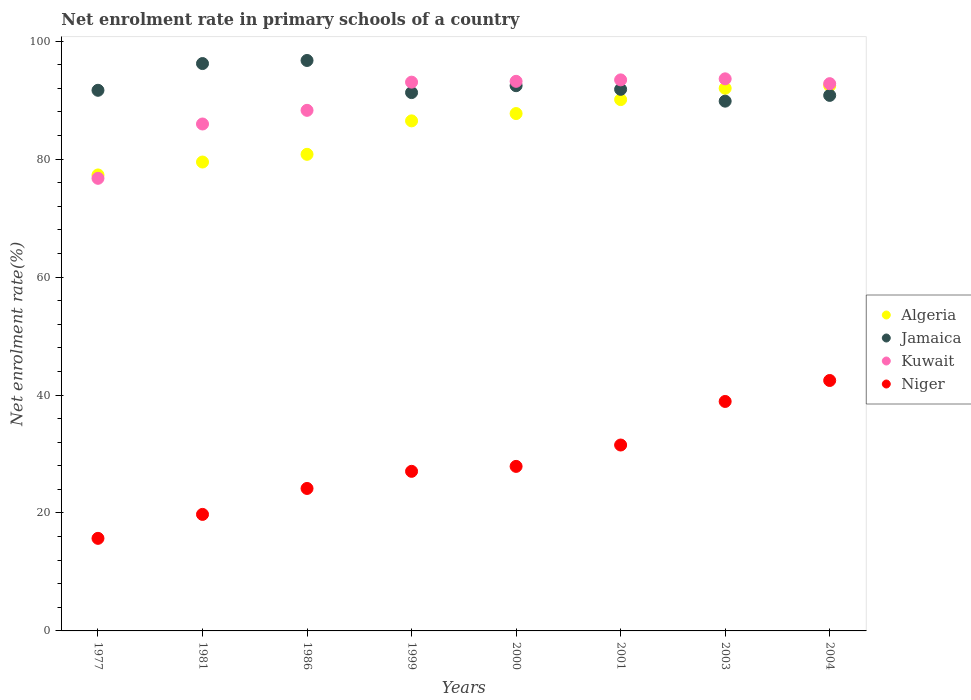How many different coloured dotlines are there?
Make the answer very short. 4. What is the net enrolment rate in primary schools in Algeria in 1999?
Make the answer very short. 86.49. Across all years, what is the maximum net enrolment rate in primary schools in Jamaica?
Ensure brevity in your answer.  96.73. Across all years, what is the minimum net enrolment rate in primary schools in Kuwait?
Your response must be concise. 76.75. In which year was the net enrolment rate in primary schools in Niger maximum?
Make the answer very short. 2004. What is the total net enrolment rate in primary schools in Kuwait in the graph?
Your answer should be very brief. 717.06. What is the difference between the net enrolment rate in primary schools in Niger in 2003 and that in 2004?
Make the answer very short. -3.55. What is the difference between the net enrolment rate in primary schools in Algeria in 2004 and the net enrolment rate in primary schools in Kuwait in 1981?
Give a very brief answer. 6.49. What is the average net enrolment rate in primary schools in Jamaica per year?
Ensure brevity in your answer.  92.6. In the year 1986, what is the difference between the net enrolment rate in primary schools in Kuwait and net enrolment rate in primary schools in Algeria?
Keep it short and to the point. 7.46. In how many years, is the net enrolment rate in primary schools in Kuwait greater than 40 %?
Offer a very short reply. 8. What is the ratio of the net enrolment rate in primary schools in Algeria in 1981 to that in 2003?
Your answer should be compact. 0.86. What is the difference between the highest and the second highest net enrolment rate in primary schools in Algeria?
Ensure brevity in your answer.  0.44. What is the difference between the highest and the lowest net enrolment rate in primary schools in Niger?
Offer a very short reply. 26.77. Is the sum of the net enrolment rate in primary schools in Niger in 2000 and 2001 greater than the maximum net enrolment rate in primary schools in Jamaica across all years?
Your response must be concise. No. Is it the case that in every year, the sum of the net enrolment rate in primary schools in Kuwait and net enrolment rate in primary schools in Jamaica  is greater than the sum of net enrolment rate in primary schools in Algeria and net enrolment rate in primary schools in Niger?
Ensure brevity in your answer.  No. Is it the case that in every year, the sum of the net enrolment rate in primary schools in Kuwait and net enrolment rate in primary schools in Niger  is greater than the net enrolment rate in primary schools in Jamaica?
Ensure brevity in your answer.  Yes. Is the net enrolment rate in primary schools in Kuwait strictly less than the net enrolment rate in primary schools in Niger over the years?
Your response must be concise. No. How many dotlines are there?
Provide a short and direct response. 4. Are the values on the major ticks of Y-axis written in scientific E-notation?
Ensure brevity in your answer.  No. How many legend labels are there?
Make the answer very short. 4. What is the title of the graph?
Your answer should be compact. Net enrolment rate in primary schools of a country. Does "Virgin Islands" appear as one of the legend labels in the graph?
Your response must be concise. No. What is the label or title of the Y-axis?
Offer a very short reply. Net enrolment rate(%). What is the Net enrolment rate(%) of Algeria in 1977?
Your answer should be compact. 77.32. What is the Net enrolment rate(%) in Jamaica in 1977?
Provide a succinct answer. 91.67. What is the Net enrolment rate(%) of Kuwait in 1977?
Provide a succinct answer. 76.75. What is the Net enrolment rate(%) of Niger in 1977?
Ensure brevity in your answer.  15.7. What is the Net enrolment rate(%) in Algeria in 1981?
Offer a terse response. 79.51. What is the Net enrolment rate(%) in Jamaica in 1981?
Your answer should be very brief. 96.2. What is the Net enrolment rate(%) of Kuwait in 1981?
Offer a very short reply. 85.96. What is the Net enrolment rate(%) of Niger in 1981?
Keep it short and to the point. 19.76. What is the Net enrolment rate(%) in Algeria in 1986?
Ensure brevity in your answer.  80.81. What is the Net enrolment rate(%) of Jamaica in 1986?
Your answer should be compact. 96.73. What is the Net enrolment rate(%) of Kuwait in 1986?
Your response must be concise. 88.27. What is the Net enrolment rate(%) in Niger in 1986?
Your answer should be very brief. 24.16. What is the Net enrolment rate(%) in Algeria in 1999?
Your answer should be compact. 86.49. What is the Net enrolment rate(%) in Jamaica in 1999?
Make the answer very short. 91.28. What is the Net enrolment rate(%) of Kuwait in 1999?
Your answer should be very brief. 93.05. What is the Net enrolment rate(%) in Niger in 1999?
Your answer should be very brief. 27.06. What is the Net enrolment rate(%) of Algeria in 2000?
Your response must be concise. 87.73. What is the Net enrolment rate(%) in Jamaica in 2000?
Your response must be concise. 92.45. What is the Net enrolment rate(%) in Kuwait in 2000?
Your answer should be compact. 93.19. What is the Net enrolment rate(%) in Niger in 2000?
Keep it short and to the point. 27.9. What is the Net enrolment rate(%) in Algeria in 2001?
Offer a very short reply. 90.09. What is the Net enrolment rate(%) in Jamaica in 2001?
Make the answer very short. 91.83. What is the Net enrolment rate(%) in Kuwait in 2001?
Your answer should be very brief. 93.44. What is the Net enrolment rate(%) in Niger in 2001?
Provide a succinct answer. 31.52. What is the Net enrolment rate(%) in Algeria in 2003?
Keep it short and to the point. 92.01. What is the Net enrolment rate(%) of Jamaica in 2003?
Offer a terse response. 89.83. What is the Net enrolment rate(%) of Kuwait in 2003?
Your answer should be very brief. 93.61. What is the Net enrolment rate(%) in Niger in 2003?
Ensure brevity in your answer.  38.91. What is the Net enrolment rate(%) of Algeria in 2004?
Offer a very short reply. 92.45. What is the Net enrolment rate(%) in Jamaica in 2004?
Your answer should be compact. 90.81. What is the Net enrolment rate(%) in Kuwait in 2004?
Your answer should be very brief. 92.79. What is the Net enrolment rate(%) of Niger in 2004?
Offer a terse response. 42.46. Across all years, what is the maximum Net enrolment rate(%) in Algeria?
Ensure brevity in your answer.  92.45. Across all years, what is the maximum Net enrolment rate(%) of Jamaica?
Your answer should be compact. 96.73. Across all years, what is the maximum Net enrolment rate(%) of Kuwait?
Your answer should be compact. 93.61. Across all years, what is the maximum Net enrolment rate(%) in Niger?
Provide a succinct answer. 42.46. Across all years, what is the minimum Net enrolment rate(%) of Algeria?
Your response must be concise. 77.32. Across all years, what is the minimum Net enrolment rate(%) in Jamaica?
Give a very brief answer. 89.83. Across all years, what is the minimum Net enrolment rate(%) of Kuwait?
Your response must be concise. 76.75. Across all years, what is the minimum Net enrolment rate(%) of Niger?
Your response must be concise. 15.7. What is the total Net enrolment rate(%) of Algeria in the graph?
Your answer should be very brief. 686.4. What is the total Net enrolment rate(%) of Jamaica in the graph?
Provide a short and direct response. 740.8. What is the total Net enrolment rate(%) of Kuwait in the graph?
Ensure brevity in your answer.  717.06. What is the total Net enrolment rate(%) of Niger in the graph?
Offer a terse response. 227.47. What is the difference between the Net enrolment rate(%) of Algeria in 1977 and that in 1981?
Your answer should be compact. -2.19. What is the difference between the Net enrolment rate(%) of Jamaica in 1977 and that in 1981?
Your answer should be compact. -4.53. What is the difference between the Net enrolment rate(%) in Kuwait in 1977 and that in 1981?
Your answer should be very brief. -9.21. What is the difference between the Net enrolment rate(%) of Niger in 1977 and that in 1981?
Ensure brevity in your answer.  -4.06. What is the difference between the Net enrolment rate(%) of Algeria in 1977 and that in 1986?
Give a very brief answer. -3.5. What is the difference between the Net enrolment rate(%) of Jamaica in 1977 and that in 1986?
Your answer should be compact. -5.06. What is the difference between the Net enrolment rate(%) in Kuwait in 1977 and that in 1986?
Keep it short and to the point. -11.53. What is the difference between the Net enrolment rate(%) of Niger in 1977 and that in 1986?
Give a very brief answer. -8.46. What is the difference between the Net enrolment rate(%) in Algeria in 1977 and that in 1999?
Provide a short and direct response. -9.17. What is the difference between the Net enrolment rate(%) of Jamaica in 1977 and that in 1999?
Offer a very short reply. 0.39. What is the difference between the Net enrolment rate(%) in Kuwait in 1977 and that in 1999?
Provide a short and direct response. -16.31. What is the difference between the Net enrolment rate(%) in Niger in 1977 and that in 1999?
Your answer should be very brief. -11.36. What is the difference between the Net enrolment rate(%) in Algeria in 1977 and that in 2000?
Offer a very short reply. -10.41. What is the difference between the Net enrolment rate(%) of Jamaica in 1977 and that in 2000?
Provide a short and direct response. -0.78. What is the difference between the Net enrolment rate(%) in Kuwait in 1977 and that in 2000?
Keep it short and to the point. -16.44. What is the difference between the Net enrolment rate(%) in Niger in 1977 and that in 2000?
Provide a short and direct response. -12.2. What is the difference between the Net enrolment rate(%) in Algeria in 1977 and that in 2001?
Offer a very short reply. -12.78. What is the difference between the Net enrolment rate(%) in Jamaica in 1977 and that in 2001?
Provide a succinct answer. -0.16. What is the difference between the Net enrolment rate(%) of Kuwait in 1977 and that in 2001?
Offer a terse response. -16.69. What is the difference between the Net enrolment rate(%) in Niger in 1977 and that in 2001?
Offer a very short reply. -15.83. What is the difference between the Net enrolment rate(%) of Algeria in 1977 and that in 2003?
Provide a succinct answer. -14.7. What is the difference between the Net enrolment rate(%) in Jamaica in 1977 and that in 2003?
Your answer should be compact. 1.84. What is the difference between the Net enrolment rate(%) in Kuwait in 1977 and that in 2003?
Your answer should be very brief. -16.87. What is the difference between the Net enrolment rate(%) of Niger in 1977 and that in 2003?
Offer a terse response. -23.21. What is the difference between the Net enrolment rate(%) in Algeria in 1977 and that in 2004?
Make the answer very short. -15.13. What is the difference between the Net enrolment rate(%) of Jamaica in 1977 and that in 2004?
Your answer should be compact. 0.86. What is the difference between the Net enrolment rate(%) in Kuwait in 1977 and that in 2004?
Keep it short and to the point. -16.05. What is the difference between the Net enrolment rate(%) of Niger in 1977 and that in 2004?
Provide a succinct answer. -26.77. What is the difference between the Net enrolment rate(%) of Algeria in 1981 and that in 1986?
Ensure brevity in your answer.  -1.31. What is the difference between the Net enrolment rate(%) of Jamaica in 1981 and that in 1986?
Your answer should be very brief. -0.52. What is the difference between the Net enrolment rate(%) of Kuwait in 1981 and that in 1986?
Provide a short and direct response. -2.32. What is the difference between the Net enrolment rate(%) in Niger in 1981 and that in 1986?
Ensure brevity in your answer.  -4.4. What is the difference between the Net enrolment rate(%) in Algeria in 1981 and that in 1999?
Offer a terse response. -6.98. What is the difference between the Net enrolment rate(%) in Jamaica in 1981 and that in 1999?
Give a very brief answer. 4.92. What is the difference between the Net enrolment rate(%) in Kuwait in 1981 and that in 1999?
Provide a succinct answer. -7.09. What is the difference between the Net enrolment rate(%) in Niger in 1981 and that in 1999?
Keep it short and to the point. -7.3. What is the difference between the Net enrolment rate(%) of Algeria in 1981 and that in 2000?
Give a very brief answer. -8.22. What is the difference between the Net enrolment rate(%) in Jamaica in 1981 and that in 2000?
Ensure brevity in your answer.  3.75. What is the difference between the Net enrolment rate(%) in Kuwait in 1981 and that in 2000?
Provide a succinct answer. -7.23. What is the difference between the Net enrolment rate(%) of Niger in 1981 and that in 2000?
Keep it short and to the point. -8.14. What is the difference between the Net enrolment rate(%) in Algeria in 1981 and that in 2001?
Provide a succinct answer. -10.59. What is the difference between the Net enrolment rate(%) of Jamaica in 1981 and that in 2001?
Keep it short and to the point. 4.37. What is the difference between the Net enrolment rate(%) of Kuwait in 1981 and that in 2001?
Make the answer very short. -7.48. What is the difference between the Net enrolment rate(%) in Niger in 1981 and that in 2001?
Keep it short and to the point. -11.76. What is the difference between the Net enrolment rate(%) in Algeria in 1981 and that in 2003?
Provide a short and direct response. -12.51. What is the difference between the Net enrolment rate(%) in Jamaica in 1981 and that in 2003?
Provide a succinct answer. 6.38. What is the difference between the Net enrolment rate(%) in Kuwait in 1981 and that in 2003?
Provide a short and direct response. -7.66. What is the difference between the Net enrolment rate(%) of Niger in 1981 and that in 2003?
Keep it short and to the point. -19.15. What is the difference between the Net enrolment rate(%) of Algeria in 1981 and that in 2004?
Your answer should be very brief. -12.94. What is the difference between the Net enrolment rate(%) of Jamaica in 1981 and that in 2004?
Your answer should be compact. 5.4. What is the difference between the Net enrolment rate(%) in Kuwait in 1981 and that in 2004?
Keep it short and to the point. -6.84. What is the difference between the Net enrolment rate(%) of Niger in 1981 and that in 2004?
Your response must be concise. -22.71. What is the difference between the Net enrolment rate(%) of Algeria in 1986 and that in 1999?
Offer a very short reply. -5.67. What is the difference between the Net enrolment rate(%) in Jamaica in 1986 and that in 1999?
Your answer should be very brief. 5.45. What is the difference between the Net enrolment rate(%) in Kuwait in 1986 and that in 1999?
Keep it short and to the point. -4.78. What is the difference between the Net enrolment rate(%) in Niger in 1986 and that in 1999?
Provide a short and direct response. -2.9. What is the difference between the Net enrolment rate(%) of Algeria in 1986 and that in 2000?
Your answer should be very brief. -6.91. What is the difference between the Net enrolment rate(%) of Jamaica in 1986 and that in 2000?
Provide a succinct answer. 4.28. What is the difference between the Net enrolment rate(%) of Kuwait in 1986 and that in 2000?
Your answer should be compact. -4.92. What is the difference between the Net enrolment rate(%) in Niger in 1986 and that in 2000?
Offer a very short reply. -3.74. What is the difference between the Net enrolment rate(%) of Algeria in 1986 and that in 2001?
Provide a succinct answer. -9.28. What is the difference between the Net enrolment rate(%) of Jamaica in 1986 and that in 2001?
Give a very brief answer. 4.89. What is the difference between the Net enrolment rate(%) in Kuwait in 1986 and that in 2001?
Your response must be concise. -5.16. What is the difference between the Net enrolment rate(%) of Niger in 1986 and that in 2001?
Provide a succinct answer. -7.37. What is the difference between the Net enrolment rate(%) in Algeria in 1986 and that in 2003?
Your answer should be very brief. -11.2. What is the difference between the Net enrolment rate(%) of Jamaica in 1986 and that in 2003?
Your answer should be very brief. 6.9. What is the difference between the Net enrolment rate(%) in Kuwait in 1986 and that in 2003?
Ensure brevity in your answer.  -5.34. What is the difference between the Net enrolment rate(%) of Niger in 1986 and that in 2003?
Ensure brevity in your answer.  -14.75. What is the difference between the Net enrolment rate(%) in Algeria in 1986 and that in 2004?
Your answer should be compact. -11.63. What is the difference between the Net enrolment rate(%) in Jamaica in 1986 and that in 2004?
Your response must be concise. 5.92. What is the difference between the Net enrolment rate(%) of Kuwait in 1986 and that in 2004?
Your response must be concise. -4.52. What is the difference between the Net enrolment rate(%) in Niger in 1986 and that in 2004?
Provide a succinct answer. -18.31. What is the difference between the Net enrolment rate(%) of Algeria in 1999 and that in 2000?
Your answer should be very brief. -1.24. What is the difference between the Net enrolment rate(%) of Jamaica in 1999 and that in 2000?
Keep it short and to the point. -1.17. What is the difference between the Net enrolment rate(%) of Kuwait in 1999 and that in 2000?
Your response must be concise. -0.14. What is the difference between the Net enrolment rate(%) of Niger in 1999 and that in 2000?
Your answer should be compact. -0.84. What is the difference between the Net enrolment rate(%) of Algeria in 1999 and that in 2001?
Keep it short and to the point. -3.61. What is the difference between the Net enrolment rate(%) of Jamaica in 1999 and that in 2001?
Ensure brevity in your answer.  -0.55. What is the difference between the Net enrolment rate(%) in Kuwait in 1999 and that in 2001?
Offer a very short reply. -0.38. What is the difference between the Net enrolment rate(%) in Niger in 1999 and that in 2001?
Provide a short and direct response. -4.46. What is the difference between the Net enrolment rate(%) in Algeria in 1999 and that in 2003?
Make the answer very short. -5.53. What is the difference between the Net enrolment rate(%) in Jamaica in 1999 and that in 2003?
Offer a very short reply. 1.45. What is the difference between the Net enrolment rate(%) in Kuwait in 1999 and that in 2003?
Ensure brevity in your answer.  -0.56. What is the difference between the Net enrolment rate(%) of Niger in 1999 and that in 2003?
Make the answer very short. -11.85. What is the difference between the Net enrolment rate(%) of Algeria in 1999 and that in 2004?
Offer a very short reply. -5.96. What is the difference between the Net enrolment rate(%) of Jamaica in 1999 and that in 2004?
Offer a very short reply. 0.47. What is the difference between the Net enrolment rate(%) of Kuwait in 1999 and that in 2004?
Your answer should be very brief. 0.26. What is the difference between the Net enrolment rate(%) of Niger in 1999 and that in 2004?
Give a very brief answer. -15.4. What is the difference between the Net enrolment rate(%) of Algeria in 2000 and that in 2001?
Your answer should be very brief. -2.37. What is the difference between the Net enrolment rate(%) of Jamaica in 2000 and that in 2001?
Your response must be concise. 0.62. What is the difference between the Net enrolment rate(%) in Kuwait in 2000 and that in 2001?
Provide a short and direct response. -0.24. What is the difference between the Net enrolment rate(%) of Niger in 2000 and that in 2001?
Keep it short and to the point. -3.62. What is the difference between the Net enrolment rate(%) in Algeria in 2000 and that in 2003?
Ensure brevity in your answer.  -4.29. What is the difference between the Net enrolment rate(%) of Jamaica in 2000 and that in 2003?
Provide a succinct answer. 2.62. What is the difference between the Net enrolment rate(%) of Kuwait in 2000 and that in 2003?
Make the answer very short. -0.42. What is the difference between the Net enrolment rate(%) of Niger in 2000 and that in 2003?
Offer a terse response. -11.01. What is the difference between the Net enrolment rate(%) in Algeria in 2000 and that in 2004?
Ensure brevity in your answer.  -4.72. What is the difference between the Net enrolment rate(%) in Jamaica in 2000 and that in 2004?
Provide a succinct answer. 1.64. What is the difference between the Net enrolment rate(%) in Kuwait in 2000 and that in 2004?
Make the answer very short. 0.4. What is the difference between the Net enrolment rate(%) of Niger in 2000 and that in 2004?
Offer a terse response. -14.57. What is the difference between the Net enrolment rate(%) of Algeria in 2001 and that in 2003?
Your response must be concise. -1.92. What is the difference between the Net enrolment rate(%) of Jamaica in 2001 and that in 2003?
Your answer should be compact. 2. What is the difference between the Net enrolment rate(%) of Kuwait in 2001 and that in 2003?
Keep it short and to the point. -0.18. What is the difference between the Net enrolment rate(%) in Niger in 2001 and that in 2003?
Your answer should be compact. -7.39. What is the difference between the Net enrolment rate(%) of Algeria in 2001 and that in 2004?
Provide a succinct answer. -2.36. What is the difference between the Net enrolment rate(%) of Jamaica in 2001 and that in 2004?
Your response must be concise. 1.03. What is the difference between the Net enrolment rate(%) in Kuwait in 2001 and that in 2004?
Ensure brevity in your answer.  0.64. What is the difference between the Net enrolment rate(%) of Niger in 2001 and that in 2004?
Your response must be concise. -10.94. What is the difference between the Net enrolment rate(%) of Algeria in 2003 and that in 2004?
Provide a short and direct response. -0.44. What is the difference between the Net enrolment rate(%) in Jamaica in 2003 and that in 2004?
Keep it short and to the point. -0.98. What is the difference between the Net enrolment rate(%) in Kuwait in 2003 and that in 2004?
Your answer should be very brief. 0.82. What is the difference between the Net enrolment rate(%) of Niger in 2003 and that in 2004?
Make the answer very short. -3.55. What is the difference between the Net enrolment rate(%) of Algeria in 1977 and the Net enrolment rate(%) of Jamaica in 1981?
Your answer should be very brief. -18.89. What is the difference between the Net enrolment rate(%) of Algeria in 1977 and the Net enrolment rate(%) of Kuwait in 1981?
Provide a succinct answer. -8.64. What is the difference between the Net enrolment rate(%) of Algeria in 1977 and the Net enrolment rate(%) of Niger in 1981?
Provide a short and direct response. 57.56. What is the difference between the Net enrolment rate(%) in Jamaica in 1977 and the Net enrolment rate(%) in Kuwait in 1981?
Offer a terse response. 5.71. What is the difference between the Net enrolment rate(%) in Jamaica in 1977 and the Net enrolment rate(%) in Niger in 1981?
Your response must be concise. 71.91. What is the difference between the Net enrolment rate(%) in Kuwait in 1977 and the Net enrolment rate(%) in Niger in 1981?
Give a very brief answer. 56.99. What is the difference between the Net enrolment rate(%) of Algeria in 1977 and the Net enrolment rate(%) of Jamaica in 1986?
Your response must be concise. -19.41. What is the difference between the Net enrolment rate(%) of Algeria in 1977 and the Net enrolment rate(%) of Kuwait in 1986?
Offer a terse response. -10.96. What is the difference between the Net enrolment rate(%) in Algeria in 1977 and the Net enrolment rate(%) in Niger in 1986?
Offer a very short reply. 53.16. What is the difference between the Net enrolment rate(%) of Jamaica in 1977 and the Net enrolment rate(%) of Kuwait in 1986?
Keep it short and to the point. 3.4. What is the difference between the Net enrolment rate(%) of Jamaica in 1977 and the Net enrolment rate(%) of Niger in 1986?
Provide a short and direct response. 67.51. What is the difference between the Net enrolment rate(%) of Kuwait in 1977 and the Net enrolment rate(%) of Niger in 1986?
Give a very brief answer. 52.59. What is the difference between the Net enrolment rate(%) in Algeria in 1977 and the Net enrolment rate(%) in Jamaica in 1999?
Offer a very short reply. -13.96. What is the difference between the Net enrolment rate(%) of Algeria in 1977 and the Net enrolment rate(%) of Kuwait in 1999?
Provide a succinct answer. -15.73. What is the difference between the Net enrolment rate(%) of Algeria in 1977 and the Net enrolment rate(%) of Niger in 1999?
Keep it short and to the point. 50.26. What is the difference between the Net enrolment rate(%) in Jamaica in 1977 and the Net enrolment rate(%) in Kuwait in 1999?
Your answer should be compact. -1.38. What is the difference between the Net enrolment rate(%) of Jamaica in 1977 and the Net enrolment rate(%) of Niger in 1999?
Provide a short and direct response. 64.61. What is the difference between the Net enrolment rate(%) of Kuwait in 1977 and the Net enrolment rate(%) of Niger in 1999?
Ensure brevity in your answer.  49.69. What is the difference between the Net enrolment rate(%) of Algeria in 1977 and the Net enrolment rate(%) of Jamaica in 2000?
Give a very brief answer. -15.13. What is the difference between the Net enrolment rate(%) of Algeria in 1977 and the Net enrolment rate(%) of Kuwait in 2000?
Your answer should be compact. -15.87. What is the difference between the Net enrolment rate(%) in Algeria in 1977 and the Net enrolment rate(%) in Niger in 2000?
Offer a very short reply. 49.42. What is the difference between the Net enrolment rate(%) in Jamaica in 1977 and the Net enrolment rate(%) in Kuwait in 2000?
Your answer should be compact. -1.52. What is the difference between the Net enrolment rate(%) in Jamaica in 1977 and the Net enrolment rate(%) in Niger in 2000?
Provide a short and direct response. 63.77. What is the difference between the Net enrolment rate(%) in Kuwait in 1977 and the Net enrolment rate(%) in Niger in 2000?
Offer a terse response. 48.85. What is the difference between the Net enrolment rate(%) in Algeria in 1977 and the Net enrolment rate(%) in Jamaica in 2001?
Provide a short and direct response. -14.52. What is the difference between the Net enrolment rate(%) of Algeria in 1977 and the Net enrolment rate(%) of Kuwait in 2001?
Offer a terse response. -16.12. What is the difference between the Net enrolment rate(%) of Algeria in 1977 and the Net enrolment rate(%) of Niger in 2001?
Make the answer very short. 45.79. What is the difference between the Net enrolment rate(%) in Jamaica in 1977 and the Net enrolment rate(%) in Kuwait in 2001?
Provide a short and direct response. -1.76. What is the difference between the Net enrolment rate(%) of Jamaica in 1977 and the Net enrolment rate(%) of Niger in 2001?
Keep it short and to the point. 60.15. What is the difference between the Net enrolment rate(%) of Kuwait in 1977 and the Net enrolment rate(%) of Niger in 2001?
Keep it short and to the point. 45.22. What is the difference between the Net enrolment rate(%) of Algeria in 1977 and the Net enrolment rate(%) of Jamaica in 2003?
Provide a succinct answer. -12.51. What is the difference between the Net enrolment rate(%) of Algeria in 1977 and the Net enrolment rate(%) of Kuwait in 2003?
Offer a terse response. -16.3. What is the difference between the Net enrolment rate(%) of Algeria in 1977 and the Net enrolment rate(%) of Niger in 2003?
Your response must be concise. 38.41. What is the difference between the Net enrolment rate(%) in Jamaica in 1977 and the Net enrolment rate(%) in Kuwait in 2003?
Your answer should be very brief. -1.94. What is the difference between the Net enrolment rate(%) in Jamaica in 1977 and the Net enrolment rate(%) in Niger in 2003?
Provide a short and direct response. 52.76. What is the difference between the Net enrolment rate(%) of Kuwait in 1977 and the Net enrolment rate(%) of Niger in 2003?
Provide a short and direct response. 37.84. What is the difference between the Net enrolment rate(%) of Algeria in 1977 and the Net enrolment rate(%) of Jamaica in 2004?
Offer a very short reply. -13.49. What is the difference between the Net enrolment rate(%) in Algeria in 1977 and the Net enrolment rate(%) in Kuwait in 2004?
Give a very brief answer. -15.48. What is the difference between the Net enrolment rate(%) of Algeria in 1977 and the Net enrolment rate(%) of Niger in 2004?
Your answer should be very brief. 34.85. What is the difference between the Net enrolment rate(%) of Jamaica in 1977 and the Net enrolment rate(%) of Kuwait in 2004?
Ensure brevity in your answer.  -1.12. What is the difference between the Net enrolment rate(%) of Jamaica in 1977 and the Net enrolment rate(%) of Niger in 2004?
Offer a terse response. 49.21. What is the difference between the Net enrolment rate(%) of Kuwait in 1977 and the Net enrolment rate(%) of Niger in 2004?
Offer a terse response. 34.28. What is the difference between the Net enrolment rate(%) of Algeria in 1981 and the Net enrolment rate(%) of Jamaica in 1986?
Offer a very short reply. -17.22. What is the difference between the Net enrolment rate(%) of Algeria in 1981 and the Net enrolment rate(%) of Kuwait in 1986?
Provide a succinct answer. -8.77. What is the difference between the Net enrolment rate(%) in Algeria in 1981 and the Net enrolment rate(%) in Niger in 1986?
Provide a short and direct response. 55.35. What is the difference between the Net enrolment rate(%) in Jamaica in 1981 and the Net enrolment rate(%) in Kuwait in 1986?
Your answer should be compact. 7.93. What is the difference between the Net enrolment rate(%) in Jamaica in 1981 and the Net enrolment rate(%) in Niger in 1986?
Make the answer very short. 72.05. What is the difference between the Net enrolment rate(%) of Kuwait in 1981 and the Net enrolment rate(%) of Niger in 1986?
Your response must be concise. 61.8. What is the difference between the Net enrolment rate(%) in Algeria in 1981 and the Net enrolment rate(%) in Jamaica in 1999?
Your answer should be very brief. -11.77. What is the difference between the Net enrolment rate(%) in Algeria in 1981 and the Net enrolment rate(%) in Kuwait in 1999?
Your response must be concise. -13.54. What is the difference between the Net enrolment rate(%) in Algeria in 1981 and the Net enrolment rate(%) in Niger in 1999?
Provide a succinct answer. 52.45. What is the difference between the Net enrolment rate(%) of Jamaica in 1981 and the Net enrolment rate(%) of Kuwait in 1999?
Give a very brief answer. 3.15. What is the difference between the Net enrolment rate(%) in Jamaica in 1981 and the Net enrolment rate(%) in Niger in 1999?
Your answer should be very brief. 69.14. What is the difference between the Net enrolment rate(%) in Kuwait in 1981 and the Net enrolment rate(%) in Niger in 1999?
Your answer should be very brief. 58.9. What is the difference between the Net enrolment rate(%) of Algeria in 1981 and the Net enrolment rate(%) of Jamaica in 2000?
Ensure brevity in your answer.  -12.94. What is the difference between the Net enrolment rate(%) of Algeria in 1981 and the Net enrolment rate(%) of Kuwait in 2000?
Keep it short and to the point. -13.68. What is the difference between the Net enrolment rate(%) in Algeria in 1981 and the Net enrolment rate(%) in Niger in 2000?
Ensure brevity in your answer.  51.61. What is the difference between the Net enrolment rate(%) in Jamaica in 1981 and the Net enrolment rate(%) in Kuwait in 2000?
Your answer should be compact. 3.01. What is the difference between the Net enrolment rate(%) of Jamaica in 1981 and the Net enrolment rate(%) of Niger in 2000?
Give a very brief answer. 68.31. What is the difference between the Net enrolment rate(%) in Kuwait in 1981 and the Net enrolment rate(%) in Niger in 2000?
Offer a terse response. 58.06. What is the difference between the Net enrolment rate(%) in Algeria in 1981 and the Net enrolment rate(%) in Jamaica in 2001?
Keep it short and to the point. -12.33. What is the difference between the Net enrolment rate(%) of Algeria in 1981 and the Net enrolment rate(%) of Kuwait in 2001?
Offer a terse response. -13.93. What is the difference between the Net enrolment rate(%) in Algeria in 1981 and the Net enrolment rate(%) in Niger in 2001?
Offer a terse response. 47.98. What is the difference between the Net enrolment rate(%) of Jamaica in 1981 and the Net enrolment rate(%) of Kuwait in 2001?
Give a very brief answer. 2.77. What is the difference between the Net enrolment rate(%) in Jamaica in 1981 and the Net enrolment rate(%) in Niger in 2001?
Provide a succinct answer. 64.68. What is the difference between the Net enrolment rate(%) of Kuwait in 1981 and the Net enrolment rate(%) of Niger in 2001?
Your answer should be very brief. 54.43. What is the difference between the Net enrolment rate(%) of Algeria in 1981 and the Net enrolment rate(%) of Jamaica in 2003?
Provide a short and direct response. -10.32. What is the difference between the Net enrolment rate(%) in Algeria in 1981 and the Net enrolment rate(%) in Kuwait in 2003?
Your answer should be compact. -14.11. What is the difference between the Net enrolment rate(%) in Algeria in 1981 and the Net enrolment rate(%) in Niger in 2003?
Provide a short and direct response. 40.6. What is the difference between the Net enrolment rate(%) of Jamaica in 1981 and the Net enrolment rate(%) of Kuwait in 2003?
Provide a succinct answer. 2.59. What is the difference between the Net enrolment rate(%) in Jamaica in 1981 and the Net enrolment rate(%) in Niger in 2003?
Make the answer very short. 57.29. What is the difference between the Net enrolment rate(%) of Kuwait in 1981 and the Net enrolment rate(%) of Niger in 2003?
Provide a short and direct response. 47.05. What is the difference between the Net enrolment rate(%) in Algeria in 1981 and the Net enrolment rate(%) in Jamaica in 2004?
Make the answer very short. -11.3. What is the difference between the Net enrolment rate(%) in Algeria in 1981 and the Net enrolment rate(%) in Kuwait in 2004?
Your answer should be compact. -13.29. What is the difference between the Net enrolment rate(%) in Algeria in 1981 and the Net enrolment rate(%) in Niger in 2004?
Offer a very short reply. 37.04. What is the difference between the Net enrolment rate(%) in Jamaica in 1981 and the Net enrolment rate(%) in Kuwait in 2004?
Your answer should be very brief. 3.41. What is the difference between the Net enrolment rate(%) in Jamaica in 1981 and the Net enrolment rate(%) in Niger in 2004?
Ensure brevity in your answer.  53.74. What is the difference between the Net enrolment rate(%) in Kuwait in 1981 and the Net enrolment rate(%) in Niger in 2004?
Give a very brief answer. 43.49. What is the difference between the Net enrolment rate(%) in Algeria in 1986 and the Net enrolment rate(%) in Jamaica in 1999?
Keep it short and to the point. -10.47. What is the difference between the Net enrolment rate(%) in Algeria in 1986 and the Net enrolment rate(%) in Kuwait in 1999?
Provide a short and direct response. -12.24. What is the difference between the Net enrolment rate(%) in Algeria in 1986 and the Net enrolment rate(%) in Niger in 1999?
Provide a succinct answer. 53.75. What is the difference between the Net enrolment rate(%) of Jamaica in 1986 and the Net enrolment rate(%) of Kuwait in 1999?
Give a very brief answer. 3.68. What is the difference between the Net enrolment rate(%) of Jamaica in 1986 and the Net enrolment rate(%) of Niger in 1999?
Offer a terse response. 69.67. What is the difference between the Net enrolment rate(%) in Kuwait in 1986 and the Net enrolment rate(%) in Niger in 1999?
Make the answer very short. 61.21. What is the difference between the Net enrolment rate(%) in Algeria in 1986 and the Net enrolment rate(%) in Jamaica in 2000?
Give a very brief answer. -11.64. What is the difference between the Net enrolment rate(%) in Algeria in 1986 and the Net enrolment rate(%) in Kuwait in 2000?
Your response must be concise. -12.38. What is the difference between the Net enrolment rate(%) of Algeria in 1986 and the Net enrolment rate(%) of Niger in 2000?
Your response must be concise. 52.91. What is the difference between the Net enrolment rate(%) of Jamaica in 1986 and the Net enrolment rate(%) of Kuwait in 2000?
Give a very brief answer. 3.54. What is the difference between the Net enrolment rate(%) of Jamaica in 1986 and the Net enrolment rate(%) of Niger in 2000?
Provide a succinct answer. 68.83. What is the difference between the Net enrolment rate(%) of Kuwait in 1986 and the Net enrolment rate(%) of Niger in 2000?
Provide a short and direct response. 60.37. What is the difference between the Net enrolment rate(%) in Algeria in 1986 and the Net enrolment rate(%) in Jamaica in 2001?
Give a very brief answer. -11.02. What is the difference between the Net enrolment rate(%) in Algeria in 1986 and the Net enrolment rate(%) in Kuwait in 2001?
Ensure brevity in your answer.  -12.62. What is the difference between the Net enrolment rate(%) in Algeria in 1986 and the Net enrolment rate(%) in Niger in 2001?
Provide a short and direct response. 49.29. What is the difference between the Net enrolment rate(%) in Jamaica in 1986 and the Net enrolment rate(%) in Kuwait in 2001?
Your answer should be very brief. 3.29. What is the difference between the Net enrolment rate(%) in Jamaica in 1986 and the Net enrolment rate(%) in Niger in 2001?
Give a very brief answer. 65.21. What is the difference between the Net enrolment rate(%) in Kuwait in 1986 and the Net enrolment rate(%) in Niger in 2001?
Your answer should be very brief. 56.75. What is the difference between the Net enrolment rate(%) of Algeria in 1986 and the Net enrolment rate(%) of Jamaica in 2003?
Keep it short and to the point. -9.01. What is the difference between the Net enrolment rate(%) in Algeria in 1986 and the Net enrolment rate(%) in Kuwait in 2003?
Ensure brevity in your answer.  -12.8. What is the difference between the Net enrolment rate(%) in Algeria in 1986 and the Net enrolment rate(%) in Niger in 2003?
Make the answer very short. 41.9. What is the difference between the Net enrolment rate(%) of Jamaica in 1986 and the Net enrolment rate(%) of Kuwait in 2003?
Give a very brief answer. 3.12. What is the difference between the Net enrolment rate(%) in Jamaica in 1986 and the Net enrolment rate(%) in Niger in 2003?
Keep it short and to the point. 57.82. What is the difference between the Net enrolment rate(%) in Kuwait in 1986 and the Net enrolment rate(%) in Niger in 2003?
Your answer should be compact. 49.36. What is the difference between the Net enrolment rate(%) of Algeria in 1986 and the Net enrolment rate(%) of Jamaica in 2004?
Make the answer very short. -9.99. What is the difference between the Net enrolment rate(%) of Algeria in 1986 and the Net enrolment rate(%) of Kuwait in 2004?
Your answer should be compact. -11.98. What is the difference between the Net enrolment rate(%) in Algeria in 1986 and the Net enrolment rate(%) in Niger in 2004?
Offer a very short reply. 38.35. What is the difference between the Net enrolment rate(%) of Jamaica in 1986 and the Net enrolment rate(%) of Kuwait in 2004?
Give a very brief answer. 3.93. What is the difference between the Net enrolment rate(%) in Jamaica in 1986 and the Net enrolment rate(%) in Niger in 2004?
Your answer should be compact. 54.26. What is the difference between the Net enrolment rate(%) of Kuwait in 1986 and the Net enrolment rate(%) of Niger in 2004?
Your answer should be compact. 45.81. What is the difference between the Net enrolment rate(%) in Algeria in 1999 and the Net enrolment rate(%) in Jamaica in 2000?
Provide a short and direct response. -5.96. What is the difference between the Net enrolment rate(%) in Algeria in 1999 and the Net enrolment rate(%) in Kuwait in 2000?
Provide a succinct answer. -6.7. What is the difference between the Net enrolment rate(%) in Algeria in 1999 and the Net enrolment rate(%) in Niger in 2000?
Give a very brief answer. 58.59. What is the difference between the Net enrolment rate(%) in Jamaica in 1999 and the Net enrolment rate(%) in Kuwait in 2000?
Make the answer very short. -1.91. What is the difference between the Net enrolment rate(%) of Jamaica in 1999 and the Net enrolment rate(%) of Niger in 2000?
Your response must be concise. 63.38. What is the difference between the Net enrolment rate(%) of Kuwait in 1999 and the Net enrolment rate(%) of Niger in 2000?
Your answer should be compact. 65.15. What is the difference between the Net enrolment rate(%) in Algeria in 1999 and the Net enrolment rate(%) in Jamaica in 2001?
Provide a short and direct response. -5.35. What is the difference between the Net enrolment rate(%) of Algeria in 1999 and the Net enrolment rate(%) of Kuwait in 2001?
Your response must be concise. -6.95. What is the difference between the Net enrolment rate(%) in Algeria in 1999 and the Net enrolment rate(%) in Niger in 2001?
Provide a short and direct response. 54.96. What is the difference between the Net enrolment rate(%) in Jamaica in 1999 and the Net enrolment rate(%) in Kuwait in 2001?
Provide a succinct answer. -2.15. What is the difference between the Net enrolment rate(%) in Jamaica in 1999 and the Net enrolment rate(%) in Niger in 2001?
Provide a succinct answer. 59.76. What is the difference between the Net enrolment rate(%) in Kuwait in 1999 and the Net enrolment rate(%) in Niger in 2001?
Ensure brevity in your answer.  61.53. What is the difference between the Net enrolment rate(%) of Algeria in 1999 and the Net enrolment rate(%) of Jamaica in 2003?
Offer a terse response. -3.34. What is the difference between the Net enrolment rate(%) of Algeria in 1999 and the Net enrolment rate(%) of Kuwait in 2003?
Provide a succinct answer. -7.13. What is the difference between the Net enrolment rate(%) in Algeria in 1999 and the Net enrolment rate(%) in Niger in 2003?
Give a very brief answer. 47.58. What is the difference between the Net enrolment rate(%) of Jamaica in 1999 and the Net enrolment rate(%) of Kuwait in 2003?
Offer a terse response. -2.33. What is the difference between the Net enrolment rate(%) of Jamaica in 1999 and the Net enrolment rate(%) of Niger in 2003?
Give a very brief answer. 52.37. What is the difference between the Net enrolment rate(%) of Kuwait in 1999 and the Net enrolment rate(%) of Niger in 2003?
Your response must be concise. 54.14. What is the difference between the Net enrolment rate(%) of Algeria in 1999 and the Net enrolment rate(%) of Jamaica in 2004?
Make the answer very short. -4.32. What is the difference between the Net enrolment rate(%) of Algeria in 1999 and the Net enrolment rate(%) of Kuwait in 2004?
Provide a succinct answer. -6.31. What is the difference between the Net enrolment rate(%) of Algeria in 1999 and the Net enrolment rate(%) of Niger in 2004?
Your answer should be very brief. 44.02. What is the difference between the Net enrolment rate(%) in Jamaica in 1999 and the Net enrolment rate(%) in Kuwait in 2004?
Make the answer very short. -1.51. What is the difference between the Net enrolment rate(%) of Jamaica in 1999 and the Net enrolment rate(%) of Niger in 2004?
Provide a short and direct response. 48.82. What is the difference between the Net enrolment rate(%) of Kuwait in 1999 and the Net enrolment rate(%) of Niger in 2004?
Your answer should be very brief. 50.59. What is the difference between the Net enrolment rate(%) of Algeria in 2000 and the Net enrolment rate(%) of Jamaica in 2001?
Your answer should be compact. -4.11. What is the difference between the Net enrolment rate(%) of Algeria in 2000 and the Net enrolment rate(%) of Kuwait in 2001?
Your response must be concise. -5.71. What is the difference between the Net enrolment rate(%) in Algeria in 2000 and the Net enrolment rate(%) in Niger in 2001?
Ensure brevity in your answer.  56.2. What is the difference between the Net enrolment rate(%) in Jamaica in 2000 and the Net enrolment rate(%) in Kuwait in 2001?
Ensure brevity in your answer.  -0.98. What is the difference between the Net enrolment rate(%) of Jamaica in 2000 and the Net enrolment rate(%) of Niger in 2001?
Make the answer very short. 60.93. What is the difference between the Net enrolment rate(%) in Kuwait in 2000 and the Net enrolment rate(%) in Niger in 2001?
Provide a succinct answer. 61.67. What is the difference between the Net enrolment rate(%) in Algeria in 2000 and the Net enrolment rate(%) in Jamaica in 2003?
Ensure brevity in your answer.  -2.1. What is the difference between the Net enrolment rate(%) in Algeria in 2000 and the Net enrolment rate(%) in Kuwait in 2003?
Provide a succinct answer. -5.89. What is the difference between the Net enrolment rate(%) of Algeria in 2000 and the Net enrolment rate(%) of Niger in 2003?
Give a very brief answer. 48.82. What is the difference between the Net enrolment rate(%) of Jamaica in 2000 and the Net enrolment rate(%) of Kuwait in 2003?
Ensure brevity in your answer.  -1.16. What is the difference between the Net enrolment rate(%) of Jamaica in 2000 and the Net enrolment rate(%) of Niger in 2003?
Ensure brevity in your answer.  53.54. What is the difference between the Net enrolment rate(%) in Kuwait in 2000 and the Net enrolment rate(%) in Niger in 2003?
Your response must be concise. 54.28. What is the difference between the Net enrolment rate(%) in Algeria in 2000 and the Net enrolment rate(%) in Jamaica in 2004?
Make the answer very short. -3.08. What is the difference between the Net enrolment rate(%) in Algeria in 2000 and the Net enrolment rate(%) in Kuwait in 2004?
Your answer should be very brief. -5.07. What is the difference between the Net enrolment rate(%) of Algeria in 2000 and the Net enrolment rate(%) of Niger in 2004?
Your response must be concise. 45.26. What is the difference between the Net enrolment rate(%) of Jamaica in 2000 and the Net enrolment rate(%) of Kuwait in 2004?
Offer a terse response. -0.34. What is the difference between the Net enrolment rate(%) in Jamaica in 2000 and the Net enrolment rate(%) in Niger in 2004?
Offer a terse response. 49.99. What is the difference between the Net enrolment rate(%) in Kuwait in 2000 and the Net enrolment rate(%) in Niger in 2004?
Your response must be concise. 50.73. What is the difference between the Net enrolment rate(%) in Algeria in 2001 and the Net enrolment rate(%) in Jamaica in 2003?
Your response must be concise. 0.26. What is the difference between the Net enrolment rate(%) of Algeria in 2001 and the Net enrolment rate(%) of Kuwait in 2003?
Keep it short and to the point. -3.52. What is the difference between the Net enrolment rate(%) in Algeria in 2001 and the Net enrolment rate(%) in Niger in 2003?
Offer a very short reply. 51.18. What is the difference between the Net enrolment rate(%) of Jamaica in 2001 and the Net enrolment rate(%) of Kuwait in 2003?
Offer a very short reply. -1.78. What is the difference between the Net enrolment rate(%) of Jamaica in 2001 and the Net enrolment rate(%) of Niger in 2003?
Ensure brevity in your answer.  52.92. What is the difference between the Net enrolment rate(%) of Kuwait in 2001 and the Net enrolment rate(%) of Niger in 2003?
Your response must be concise. 54.53. What is the difference between the Net enrolment rate(%) in Algeria in 2001 and the Net enrolment rate(%) in Jamaica in 2004?
Your response must be concise. -0.72. What is the difference between the Net enrolment rate(%) in Algeria in 2001 and the Net enrolment rate(%) in Kuwait in 2004?
Ensure brevity in your answer.  -2.7. What is the difference between the Net enrolment rate(%) of Algeria in 2001 and the Net enrolment rate(%) of Niger in 2004?
Provide a short and direct response. 47.63. What is the difference between the Net enrolment rate(%) in Jamaica in 2001 and the Net enrolment rate(%) in Kuwait in 2004?
Make the answer very short. -0.96. What is the difference between the Net enrolment rate(%) of Jamaica in 2001 and the Net enrolment rate(%) of Niger in 2004?
Offer a terse response. 49.37. What is the difference between the Net enrolment rate(%) of Kuwait in 2001 and the Net enrolment rate(%) of Niger in 2004?
Offer a terse response. 50.97. What is the difference between the Net enrolment rate(%) of Algeria in 2003 and the Net enrolment rate(%) of Jamaica in 2004?
Make the answer very short. 1.21. What is the difference between the Net enrolment rate(%) of Algeria in 2003 and the Net enrolment rate(%) of Kuwait in 2004?
Give a very brief answer. -0.78. What is the difference between the Net enrolment rate(%) in Algeria in 2003 and the Net enrolment rate(%) in Niger in 2004?
Offer a terse response. 49.55. What is the difference between the Net enrolment rate(%) of Jamaica in 2003 and the Net enrolment rate(%) of Kuwait in 2004?
Make the answer very short. -2.97. What is the difference between the Net enrolment rate(%) in Jamaica in 2003 and the Net enrolment rate(%) in Niger in 2004?
Your response must be concise. 47.36. What is the difference between the Net enrolment rate(%) of Kuwait in 2003 and the Net enrolment rate(%) of Niger in 2004?
Ensure brevity in your answer.  51.15. What is the average Net enrolment rate(%) of Algeria per year?
Your response must be concise. 85.8. What is the average Net enrolment rate(%) in Jamaica per year?
Provide a short and direct response. 92.6. What is the average Net enrolment rate(%) of Kuwait per year?
Give a very brief answer. 89.63. What is the average Net enrolment rate(%) of Niger per year?
Provide a short and direct response. 28.43. In the year 1977, what is the difference between the Net enrolment rate(%) of Algeria and Net enrolment rate(%) of Jamaica?
Provide a short and direct response. -14.35. In the year 1977, what is the difference between the Net enrolment rate(%) of Algeria and Net enrolment rate(%) of Kuwait?
Give a very brief answer. 0.57. In the year 1977, what is the difference between the Net enrolment rate(%) of Algeria and Net enrolment rate(%) of Niger?
Provide a short and direct response. 61.62. In the year 1977, what is the difference between the Net enrolment rate(%) of Jamaica and Net enrolment rate(%) of Kuwait?
Provide a short and direct response. 14.92. In the year 1977, what is the difference between the Net enrolment rate(%) in Jamaica and Net enrolment rate(%) in Niger?
Keep it short and to the point. 75.97. In the year 1977, what is the difference between the Net enrolment rate(%) in Kuwait and Net enrolment rate(%) in Niger?
Make the answer very short. 61.05. In the year 1981, what is the difference between the Net enrolment rate(%) of Algeria and Net enrolment rate(%) of Jamaica?
Your response must be concise. -16.7. In the year 1981, what is the difference between the Net enrolment rate(%) in Algeria and Net enrolment rate(%) in Kuwait?
Keep it short and to the point. -6.45. In the year 1981, what is the difference between the Net enrolment rate(%) in Algeria and Net enrolment rate(%) in Niger?
Ensure brevity in your answer.  59.75. In the year 1981, what is the difference between the Net enrolment rate(%) of Jamaica and Net enrolment rate(%) of Kuwait?
Your response must be concise. 10.25. In the year 1981, what is the difference between the Net enrolment rate(%) in Jamaica and Net enrolment rate(%) in Niger?
Offer a very short reply. 76.45. In the year 1981, what is the difference between the Net enrolment rate(%) of Kuwait and Net enrolment rate(%) of Niger?
Provide a short and direct response. 66.2. In the year 1986, what is the difference between the Net enrolment rate(%) in Algeria and Net enrolment rate(%) in Jamaica?
Offer a terse response. -15.91. In the year 1986, what is the difference between the Net enrolment rate(%) of Algeria and Net enrolment rate(%) of Kuwait?
Make the answer very short. -7.46. In the year 1986, what is the difference between the Net enrolment rate(%) of Algeria and Net enrolment rate(%) of Niger?
Provide a short and direct response. 56.66. In the year 1986, what is the difference between the Net enrolment rate(%) in Jamaica and Net enrolment rate(%) in Kuwait?
Your answer should be compact. 8.46. In the year 1986, what is the difference between the Net enrolment rate(%) of Jamaica and Net enrolment rate(%) of Niger?
Provide a short and direct response. 72.57. In the year 1986, what is the difference between the Net enrolment rate(%) in Kuwait and Net enrolment rate(%) in Niger?
Provide a short and direct response. 64.11. In the year 1999, what is the difference between the Net enrolment rate(%) in Algeria and Net enrolment rate(%) in Jamaica?
Your answer should be very brief. -4.8. In the year 1999, what is the difference between the Net enrolment rate(%) in Algeria and Net enrolment rate(%) in Kuwait?
Your answer should be very brief. -6.56. In the year 1999, what is the difference between the Net enrolment rate(%) in Algeria and Net enrolment rate(%) in Niger?
Keep it short and to the point. 59.43. In the year 1999, what is the difference between the Net enrolment rate(%) in Jamaica and Net enrolment rate(%) in Kuwait?
Offer a terse response. -1.77. In the year 1999, what is the difference between the Net enrolment rate(%) of Jamaica and Net enrolment rate(%) of Niger?
Offer a terse response. 64.22. In the year 1999, what is the difference between the Net enrolment rate(%) in Kuwait and Net enrolment rate(%) in Niger?
Make the answer very short. 65.99. In the year 2000, what is the difference between the Net enrolment rate(%) of Algeria and Net enrolment rate(%) of Jamaica?
Provide a short and direct response. -4.72. In the year 2000, what is the difference between the Net enrolment rate(%) in Algeria and Net enrolment rate(%) in Kuwait?
Your answer should be very brief. -5.46. In the year 2000, what is the difference between the Net enrolment rate(%) in Algeria and Net enrolment rate(%) in Niger?
Give a very brief answer. 59.83. In the year 2000, what is the difference between the Net enrolment rate(%) in Jamaica and Net enrolment rate(%) in Kuwait?
Ensure brevity in your answer.  -0.74. In the year 2000, what is the difference between the Net enrolment rate(%) of Jamaica and Net enrolment rate(%) of Niger?
Offer a very short reply. 64.55. In the year 2000, what is the difference between the Net enrolment rate(%) in Kuwait and Net enrolment rate(%) in Niger?
Your answer should be very brief. 65.29. In the year 2001, what is the difference between the Net enrolment rate(%) in Algeria and Net enrolment rate(%) in Jamaica?
Offer a terse response. -1.74. In the year 2001, what is the difference between the Net enrolment rate(%) in Algeria and Net enrolment rate(%) in Kuwait?
Offer a terse response. -3.34. In the year 2001, what is the difference between the Net enrolment rate(%) of Algeria and Net enrolment rate(%) of Niger?
Your answer should be compact. 58.57. In the year 2001, what is the difference between the Net enrolment rate(%) of Jamaica and Net enrolment rate(%) of Kuwait?
Provide a short and direct response. -1.6. In the year 2001, what is the difference between the Net enrolment rate(%) in Jamaica and Net enrolment rate(%) in Niger?
Ensure brevity in your answer.  60.31. In the year 2001, what is the difference between the Net enrolment rate(%) in Kuwait and Net enrolment rate(%) in Niger?
Your response must be concise. 61.91. In the year 2003, what is the difference between the Net enrolment rate(%) in Algeria and Net enrolment rate(%) in Jamaica?
Give a very brief answer. 2.18. In the year 2003, what is the difference between the Net enrolment rate(%) of Algeria and Net enrolment rate(%) of Kuwait?
Your response must be concise. -1.6. In the year 2003, what is the difference between the Net enrolment rate(%) in Algeria and Net enrolment rate(%) in Niger?
Offer a terse response. 53.1. In the year 2003, what is the difference between the Net enrolment rate(%) in Jamaica and Net enrolment rate(%) in Kuwait?
Your response must be concise. -3.78. In the year 2003, what is the difference between the Net enrolment rate(%) of Jamaica and Net enrolment rate(%) of Niger?
Keep it short and to the point. 50.92. In the year 2003, what is the difference between the Net enrolment rate(%) of Kuwait and Net enrolment rate(%) of Niger?
Your answer should be very brief. 54.7. In the year 2004, what is the difference between the Net enrolment rate(%) of Algeria and Net enrolment rate(%) of Jamaica?
Offer a very short reply. 1.64. In the year 2004, what is the difference between the Net enrolment rate(%) in Algeria and Net enrolment rate(%) in Kuwait?
Your answer should be compact. -0.35. In the year 2004, what is the difference between the Net enrolment rate(%) of Algeria and Net enrolment rate(%) of Niger?
Provide a succinct answer. 49.98. In the year 2004, what is the difference between the Net enrolment rate(%) in Jamaica and Net enrolment rate(%) in Kuwait?
Offer a terse response. -1.99. In the year 2004, what is the difference between the Net enrolment rate(%) in Jamaica and Net enrolment rate(%) in Niger?
Provide a succinct answer. 48.34. In the year 2004, what is the difference between the Net enrolment rate(%) in Kuwait and Net enrolment rate(%) in Niger?
Keep it short and to the point. 50.33. What is the ratio of the Net enrolment rate(%) in Algeria in 1977 to that in 1981?
Your answer should be compact. 0.97. What is the ratio of the Net enrolment rate(%) in Jamaica in 1977 to that in 1981?
Provide a succinct answer. 0.95. What is the ratio of the Net enrolment rate(%) in Kuwait in 1977 to that in 1981?
Provide a succinct answer. 0.89. What is the ratio of the Net enrolment rate(%) in Niger in 1977 to that in 1981?
Your answer should be compact. 0.79. What is the ratio of the Net enrolment rate(%) in Algeria in 1977 to that in 1986?
Offer a very short reply. 0.96. What is the ratio of the Net enrolment rate(%) of Jamaica in 1977 to that in 1986?
Provide a succinct answer. 0.95. What is the ratio of the Net enrolment rate(%) in Kuwait in 1977 to that in 1986?
Your response must be concise. 0.87. What is the ratio of the Net enrolment rate(%) in Niger in 1977 to that in 1986?
Keep it short and to the point. 0.65. What is the ratio of the Net enrolment rate(%) in Algeria in 1977 to that in 1999?
Ensure brevity in your answer.  0.89. What is the ratio of the Net enrolment rate(%) in Kuwait in 1977 to that in 1999?
Your response must be concise. 0.82. What is the ratio of the Net enrolment rate(%) in Niger in 1977 to that in 1999?
Provide a short and direct response. 0.58. What is the ratio of the Net enrolment rate(%) in Algeria in 1977 to that in 2000?
Provide a short and direct response. 0.88. What is the ratio of the Net enrolment rate(%) in Jamaica in 1977 to that in 2000?
Your answer should be compact. 0.99. What is the ratio of the Net enrolment rate(%) of Kuwait in 1977 to that in 2000?
Ensure brevity in your answer.  0.82. What is the ratio of the Net enrolment rate(%) in Niger in 1977 to that in 2000?
Provide a succinct answer. 0.56. What is the ratio of the Net enrolment rate(%) in Algeria in 1977 to that in 2001?
Your answer should be very brief. 0.86. What is the ratio of the Net enrolment rate(%) in Kuwait in 1977 to that in 2001?
Your answer should be compact. 0.82. What is the ratio of the Net enrolment rate(%) in Niger in 1977 to that in 2001?
Provide a short and direct response. 0.5. What is the ratio of the Net enrolment rate(%) in Algeria in 1977 to that in 2003?
Ensure brevity in your answer.  0.84. What is the ratio of the Net enrolment rate(%) of Jamaica in 1977 to that in 2003?
Your answer should be very brief. 1.02. What is the ratio of the Net enrolment rate(%) in Kuwait in 1977 to that in 2003?
Offer a terse response. 0.82. What is the ratio of the Net enrolment rate(%) in Niger in 1977 to that in 2003?
Offer a terse response. 0.4. What is the ratio of the Net enrolment rate(%) in Algeria in 1977 to that in 2004?
Ensure brevity in your answer.  0.84. What is the ratio of the Net enrolment rate(%) of Jamaica in 1977 to that in 2004?
Provide a succinct answer. 1.01. What is the ratio of the Net enrolment rate(%) in Kuwait in 1977 to that in 2004?
Provide a short and direct response. 0.83. What is the ratio of the Net enrolment rate(%) of Niger in 1977 to that in 2004?
Make the answer very short. 0.37. What is the ratio of the Net enrolment rate(%) in Algeria in 1981 to that in 1986?
Your answer should be compact. 0.98. What is the ratio of the Net enrolment rate(%) of Kuwait in 1981 to that in 1986?
Offer a very short reply. 0.97. What is the ratio of the Net enrolment rate(%) of Niger in 1981 to that in 1986?
Keep it short and to the point. 0.82. What is the ratio of the Net enrolment rate(%) in Algeria in 1981 to that in 1999?
Your response must be concise. 0.92. What is the ratio of the Net enrolment rate(%) in Jamaica in 1981 to that in 1999?
Keep it short and to the point. 1.05. What is the ratio of the Net enrolment rate(%) in Kuwait in 1981 to that in 1999?
Offer a very short reply. 0.92. What is the ratio of the Net enrolment rate(%) of Niger in 1981 to that in 1999?
Offer a very short reply. 0.73. What is the ratio of the Net enrolment rate(%) of Algeria in 1981 to that in 2000?
Provide a succinct answer. 0.91. What is the ratio of the Net enrolment rate(%) in Jamaica in 1981 to that in 2000?
Your response must be concise. 1.04. What is the ratio of the Net enrolment rate(%) of Kuwait in 1981 to that in 2000?
Ensure brevity in your answer.  0.92. What is the ratio of the Net enrolment rate(%) in Niger in 1981 to that in 2000?
Your answer should be very brief. 0.71. What is the ratio of the Net enrolment rate(%) of Algeria in 1981 to that in 2001?
Provide a succinct answer. 0.88. What is the ratio of the Net enrolment rate(%) of Jamaica in 1981 to that in 2001?
Your response must be concise. 1.05. What is the ratio of the Net enrolment rate(%) of Kuwait in 1981 to that in 2001?
Your answer should be compact. 0.92. What is the ratio of the Net enrolment rate(%) in Niger in 1981 to that in 2001?
Ensure brevity in your answer.  0.63. What is the ratio of the Net enrolment rate(%) in Algeria in 1981 to that in 2003?
Provide a short and direct response. 0.86. What is the ratio of the Net enrolment rate(%) of Jamaica in 1981 to that in 2003?
Provide a succinct answer. 1.07. What is the ratio of the Net enrolment rate(%) in Kuwait in 1981 to that in 2003?
Make the answer very short. 0.92. What is the ratio of the Net enrolment rate(%) of Niger in 1981 to that in 2003?
Make the answer very short. 0.51. What is the ratio of the Net enrolment rate(%) in Algeria in 1981 to that in 2004?
Keep it short and to the point. 0.86. What is the ratio of the Net enrolment rate(%) in Jamaica in 1981 to that in 2004?
Offer a very short reply. 1.06. What is the ratio of the Net enrolment rate(%) in Kuwait in 1981 to that in 2004?
Provide a short and direct response. 0.93. What is the ratio of the Net enrolment rate(%) of Niger in 1981 to that in 2004?
Provide a succinct answer. 0.47. What is the ratio of the Net enrolment rate(%) of Algeria in 1986 to that in 1999?
Provide a succinct answer. 0.93. What is the ratio of the Net enrolment rate(%) in Jamaica in 1986 to that in 1999?
Your answer should be compact. 1.06. What is the ratio of the Net enrolment rate(%) of Kuwait in 1986 to that in 1999?
Offer a very short reply. 0.95. What is the ratio of the Net enrolment rate(%) of Niger in 1986 to that in 1999?
Make the answer very short. 0.89. What is the ratio of the Net enrolment rate(%) of Algeria in 1986 to that in 2000?
Your answer should be compact. 0.92. What is the ratio of the Net enrolment rate(%) in Jamaica in 1986 to that in 2000?
Offer a terse response. 1.05. What is the ratio of the Net enrolment rate(%) in Kuwait in 1986 to that in 2000?
Your response must be concise. 0.95. What is the ratio of the Net enrolment rate(%) in Niger in 1986 to that in 2000?
Keep it short and to the point. 0.87. What is the ratio of the Net enrolment rate(%) in Algeria in 1986 to that in 2001?
Keep it short and to the point. 0.9. What is the ratio of the Net enrolment rate(%) in Jamaica in 1986 to that in 2001?
Ensure brevity in your answer.  1.05. What is the ratio of the Net enrolment rate(%) in Kuwait in 1986 to that in 2001?
Give a very brief answer. 0.94. What is the ratio of the Net enrolment rate(%) in Niger in 1986 to that in 2001?
Offer a terse response. 0.77. What is the ratio of the Net enrolment rate(%) of Algeria in 1986 to that in 2003?
Give a very brief answer. 0.88. What is the ratio of the Net enrolment rate(%) of Jamaica in 1986 to that in 2003?
Ensure brevity in your answer.  1.08. What is the ratio of the Net enrolment rate(%) of Kuwait in 1986 to that in 2003?
Provide a short and direct response. 0.94. What is the ratio of the Net enrolment rate(%) in Niger in 1986 to that in 2003?
Provide a short and direct response. 0.62. What is the ratio of the Net enrolment rate(%) in Algeria in 1986 to that in 2004?
Provide a succinct answer. 0.87. What is the ratio of the Net enrolment rate(%) of Jamaica in 1986 to that in 2004?
Make the answer very short. 1.07. What is the ratio of the Net enrolment rate(%) of Kuwait in 1986 to that in 2004?
Your response must be concise. 0.95. What is the ratio of the Net enrolment rate(%) in Niger in 1986 to that in 2004?
Provide a succinct answer. 0.57. What is the ratio of the Net enrolment rate(%) in Algeria in 1999 to that in 2000?
Provide a short and direct response. 0.99. What is the ratio of the Net enrolment rate(%) in Jamaica in 1999 to that in 2000?
Provide a short and direct response. 0.99. What is the ratio of the Net enrolment rate(%) in Kuwait in 1999 to that in 2000?
Offer a terse response. 1. What is the ratio of the Net enrolment rate(%) in Niger in 1999 to that in 2000?
Provide a succinct answer. 0.97. What is the ratio of the Net enrolment rate(%) of Algeria in 1999 to that in 2001?
Your response must be concise. 0.96. What is the ratio of the Net enrolment rate(%) in Kuwait in 1999 to that in 2001?
Offer a terse response. 1. What is the ratio of the Net enrolment rate(%) of Niger in 1999 to that in 2001?
Provide a short and direct response. 0.86. What is the ratio of the Net enrolment rate(%) of Algeria in 1999 to that in 2003?
Provide a succinct answer. 0.94. What is the ratio of the Net enrolment rate(%) in Jamaica in 1999 to that in 2003?
Your answer should be compact. 1.02. What is the ratio of the Net enrolment rate(%) of Niger in 1999 to that in 2003?
Ensure brevity in your answer.  0.7. What is the ratio of the Net enrolment rate(%) of Algeria in 1999 to that in 2004?
Your answer should be very brief. 0.94. What is the ratio of the Net enrolment rate(%) of Niger in 1999 to that in 2004?
Give a very brief answer. 0.64. What is the ratio of the Net enrolment rate(%) of Algeria in 2000 to that in 2001?
Your answer should be compact. 0.97. What is the ratio of the Net enrolment rate(%) of Kuwait in 2000 to that in 2001?
Your answer should be compact. 1. What is the ratio of the Net enrolment rate(%) in Niger in 2000 to that in 2001?
Keep it short and to the point. 0.89. What is the ratio of the Net enrolment rate(%) of Algeria in 2000 to that in 2003?
Offer a terse response. 0.95. What is the ratio of the Net enrolment rate(%) in Jamaica in 2000 to that in 2003?
Offer a very short reply. 1.03. What is the ratio of the Net enrolment rate(%) in Kuwait in 2000 to that in 2003?
Provide a short and direct response. 1. What is the ratio of the Net enrolment rate(%) in Niger in 2000 to that in 2003?
Offer a terse response. 0.72. What is the ratio of the Net enrolment rate(%) in Algeria in 2000 to that in 2004?
Offer a very short reply. 0.95. What is the ratio of the Net enrolment rate(%) of Jamaica in 2000 to that in 2004?
Make the answer very short. 1.02. What is the ratio of the Net enrolment rate(%) of Niger in 2000 to that in 2004?
Provide a short and direct response. 0.66. What is the ratio of the Net enrolment rate(%) in Algeria in 2001 to that in 2003?
Ensure brevity in your answer.  0.98. What is the ratio of the Net enrolment rate(%) of Jamaica in 2001 to that in 2003?
Make the answer very short. 1.02. What is the ratio of the Net enrolment rate(%) in Niger in 2001 to that in 2003?
Provide a short and direct response. 0.81. What is the ratio of the Net enrolment rate(%) of Algeria in 2001 to that in 2004?
Your response must be concise. 0.97. What is the ratio of the Net enrolment rate(%) of Jamaica in 2001 to that in 2004?
Offer a terse response. 1.01. What is the ratio of the Net enrolment rate(%) in Niger in 2001 to that in 2004?
Your answer should be very brief. 0.74. What is the ratio of the Net enrolment rate(%) of Algeria in 2003 to that in 2004?
Offer a very short reply. 1. What is the ratio of the Net enrolment rate(%) in Kuwait in 2003 to that in 2004?
Make the answer very short. 1.01. What is the ratio of the Net enrolment rate(%) of Niger in 2003 to that in 2004?
Ensure brevity in your answer.  0.92. What is the difference between the highest and the second highest Net enrolment rate(%) of Algeria?
Ensure brevity in your answer.  0.44. What is the difference between the highest and the second highest Net enrolment rate(%) in Jamaica?
Keep it short and to the point. 0.52. What is the difference between the highest and the second highest Net enrolment rate(%) of Kuwait?
Make the answer very short. 0.18. What is the difference between the highest and the second highest Net enrolment rate(%) in Niger?
Make the answer very short. 3.55. What is the difference between the highest and the lowest Net enrolment rate(%) of Algeria?
Provide a succinct answer. 15.13. What is the difference between the highest and the lowest Net enrolment rate(%) in Jamaica?
Give a very brief answer. 6.9. What is the difference between the highest and the lowest Net enrolment rate(%) of Kuwait?
Your answer should be very brief. 16.87. What is the difference between the highest and the lowest Net enrolment rate(%) of Niger?
Your answer should be compact. 26.77. 